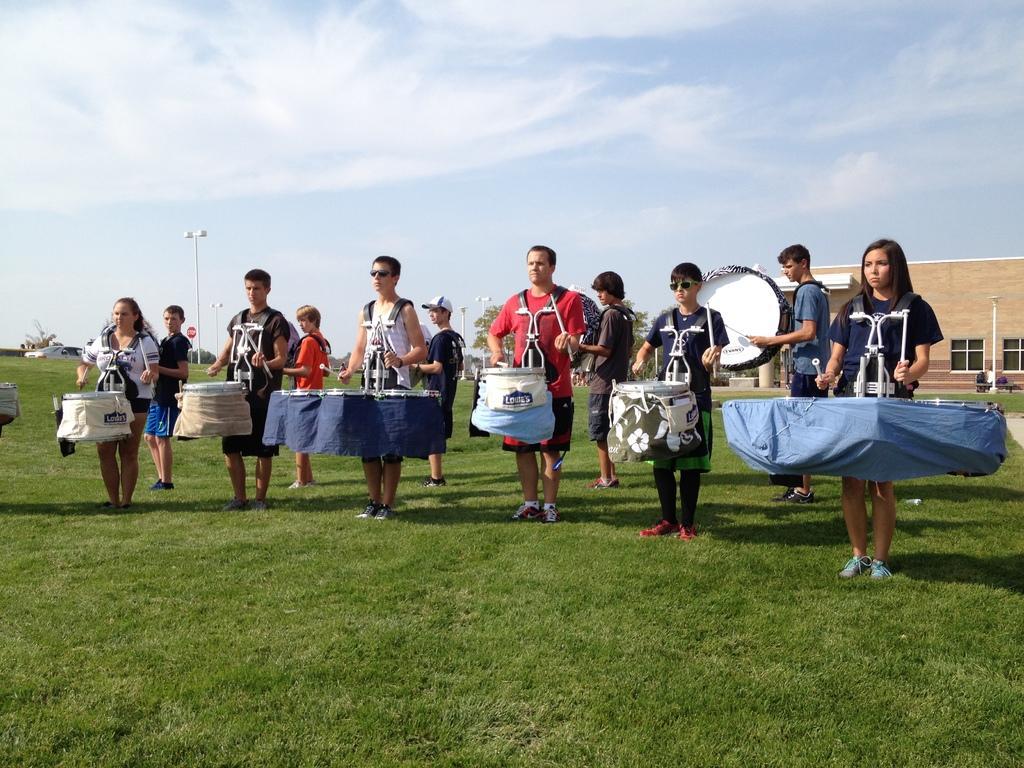In one or two sentences, can you explain what this image depicts? As we can see in the image in the front there are group of people playing drums. There is a building, few lights and grass. At the top there is sky and there are clouds. 